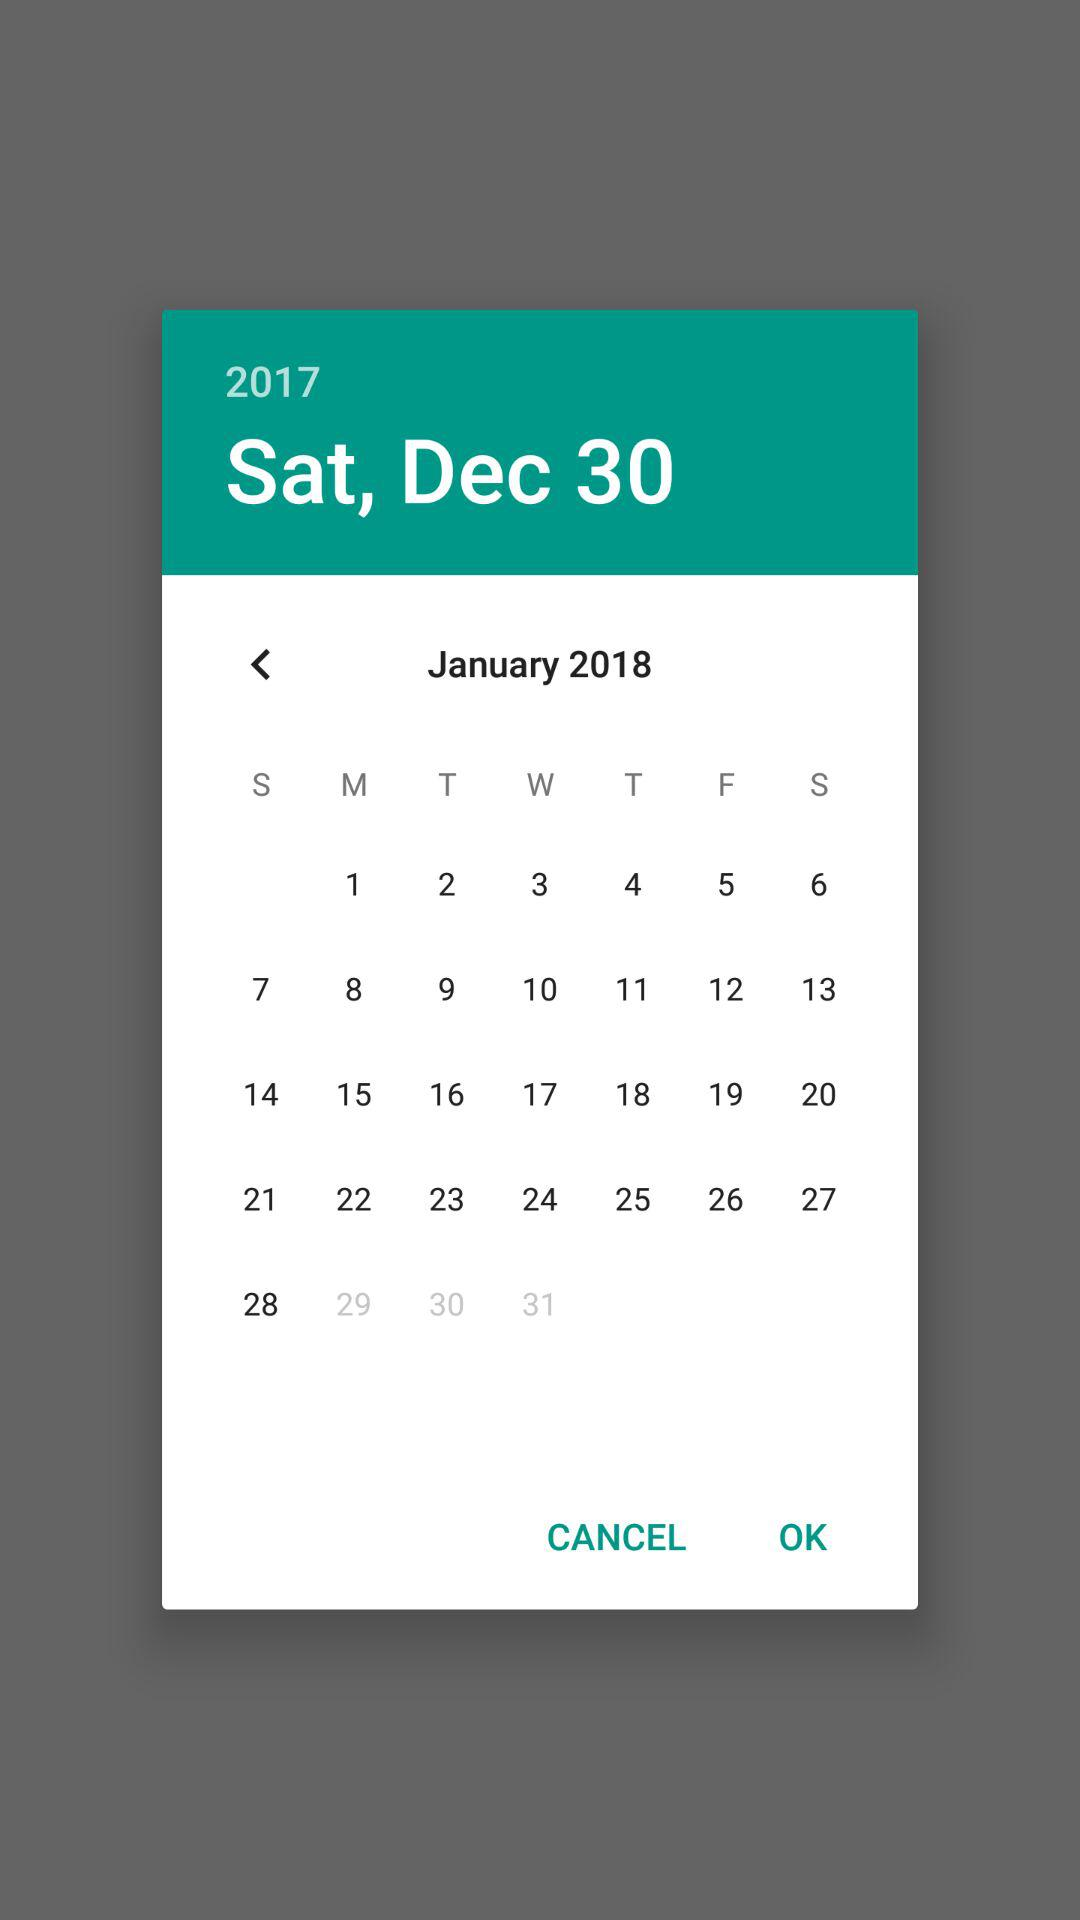What is the day on December 30, 2017? The day on December 30, 2017 is Tuesday. 